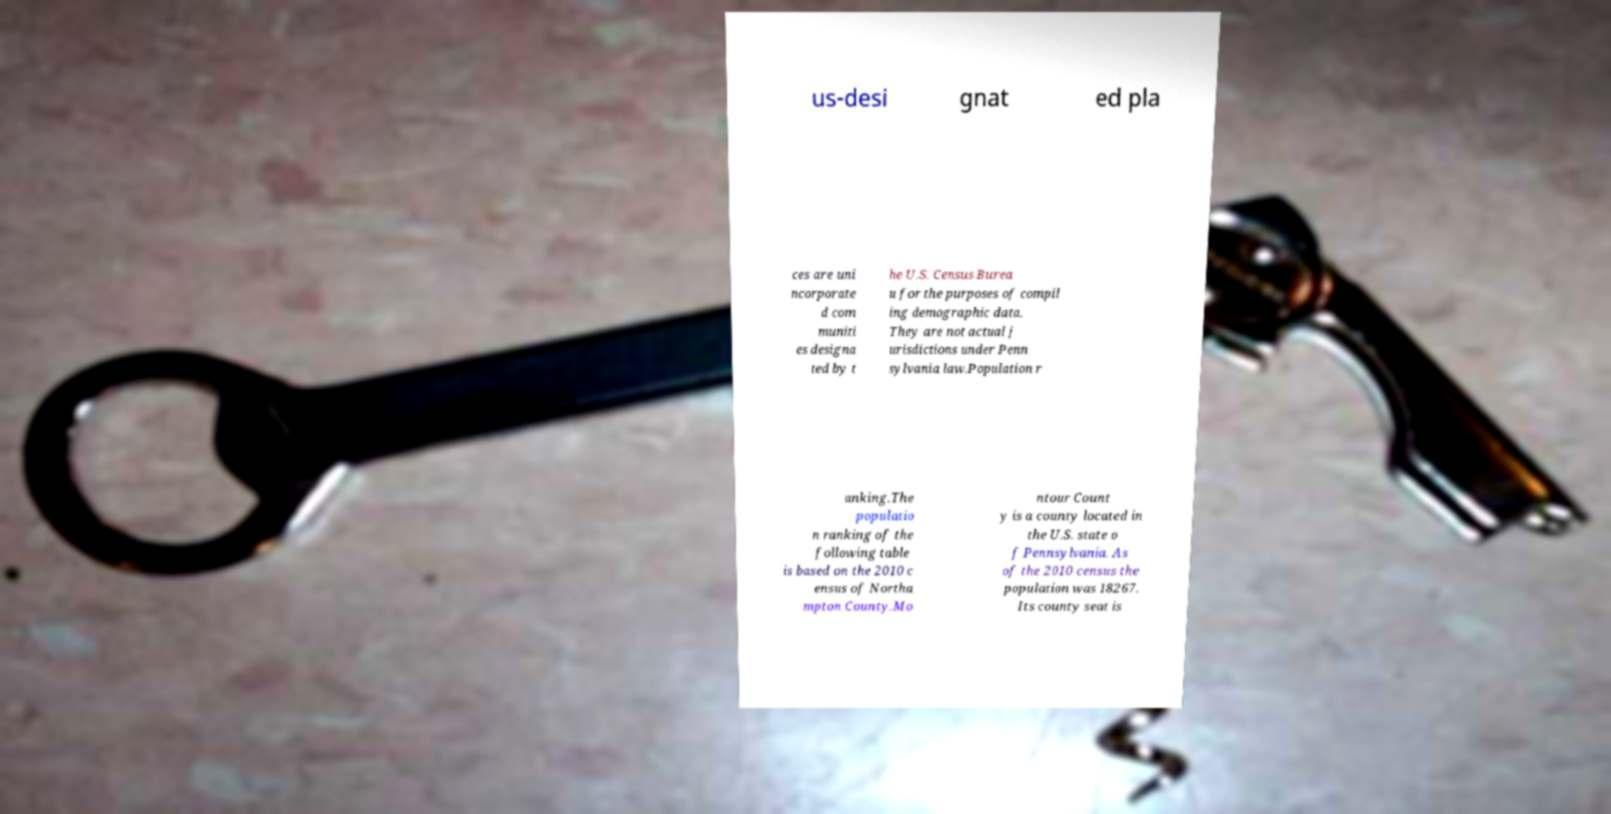I need the written content from this picture converted into text. Can you do that? us-desi gnat ed pla ces are uni ncorporate d com muniti es designa ted by t he U.S. Census Burea u for the purposes of compil ing demographic data. They are not actual j urisdictions under Penn sylvania law.Population r anking.The populatio n ranking of the following table is based on the 2010 c ensus of Northa mpton County.Mo ntour Count y is a county located in the U.S. state o f Pennsylvania. As of the 2010 census the population was 18267. Its county seat is 